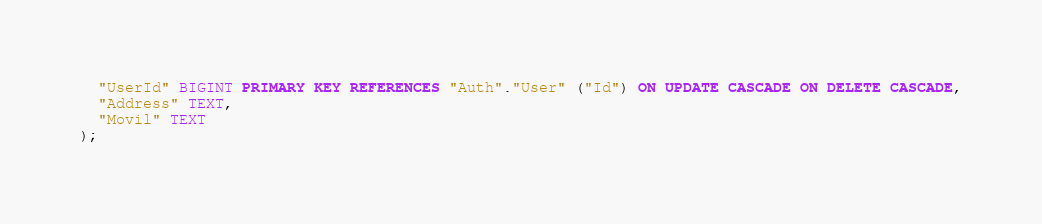Convert code to text. <code><loc_0><loc_0><loc_500><loc_500><_SQL_>  "UserId" BIGINT PRIMARY KEY REFERENCES "Auth"."User" ("Id") ON UPDATE CASCADE ON DELETE CASCADE,
  "Address" TEXT,
  "Movil" TEXT
);
</code> 